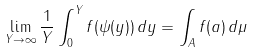<formula> <loc_0><loc_0><loc_500><loc_500>\lim _ { Y \to \infty } \frac { 1 } { Y } \int _ { 0 } ^ { Y } f ( \psi ( y ) ) \, d y & = \int _ { A } f ( a ) \, d \mu \\</formula> 